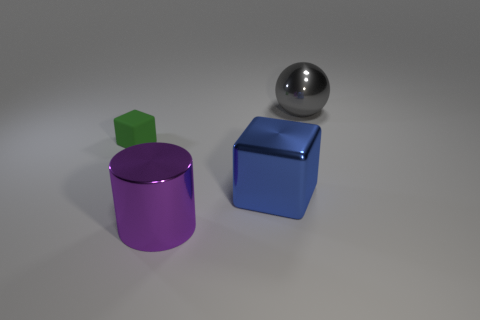Add 4 big gray shiny spheres. How many objects exist? 8 Subtract all spheres. How many objects are left? 3 Subtract all purple blocks. Subtract all yellow cylinders. How many blocks are left? 2 Subtract all large things. Subtract all small cyan matte balls. How many objects are left? 1 Add 3 big metal blocks. How many big metal blocks are left? 4 Add 4 large yellow metal objects. How many large yellow metal objects exist? 4 Subtract 0 green cylinders. How many objects are left? 4 